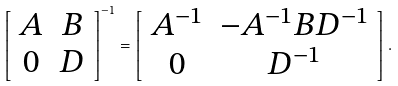Convert formula to latex. <formula><loc_0><loc_0><loc_500><loc_500>\left [ \begin{array} { c c } A & B \\ 0 & D \end{array} \right ] ^ { - 1 } = \left [ \begin{array} { c c } A ^ { - 1 } & - A ^ { - 1 } B D ^ { - 1 } \\ 0 & D ^ { - 1 } \end{array} \right ] .</formula> 